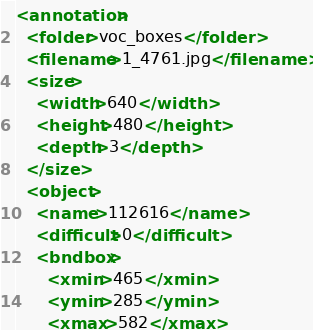Convert code to text. <code><loc_0><loc_0><loc_500><loc_500><_XML_><annotation>
  <folder>voc_boxes</folder>
  <filename>1_4761.jpg</filename>
  <size>
    <width>640</width>
    <height>480</height>
    <depth>3</depth>
  </size>
  <object>
    <name>112616</name>
    <difficult>0</difficult>
    <bndbox>
      <xmin>465</xmin>
      <ymin>285</ymin>
      <xmax>582</xmax></code> 